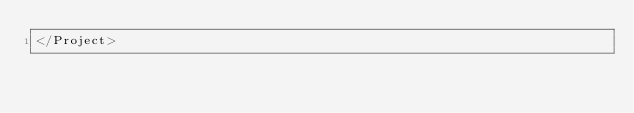Convert code to text. <code><loc_0><loc_0><loc_500><loc_500><_XML_></Project>
</code> 